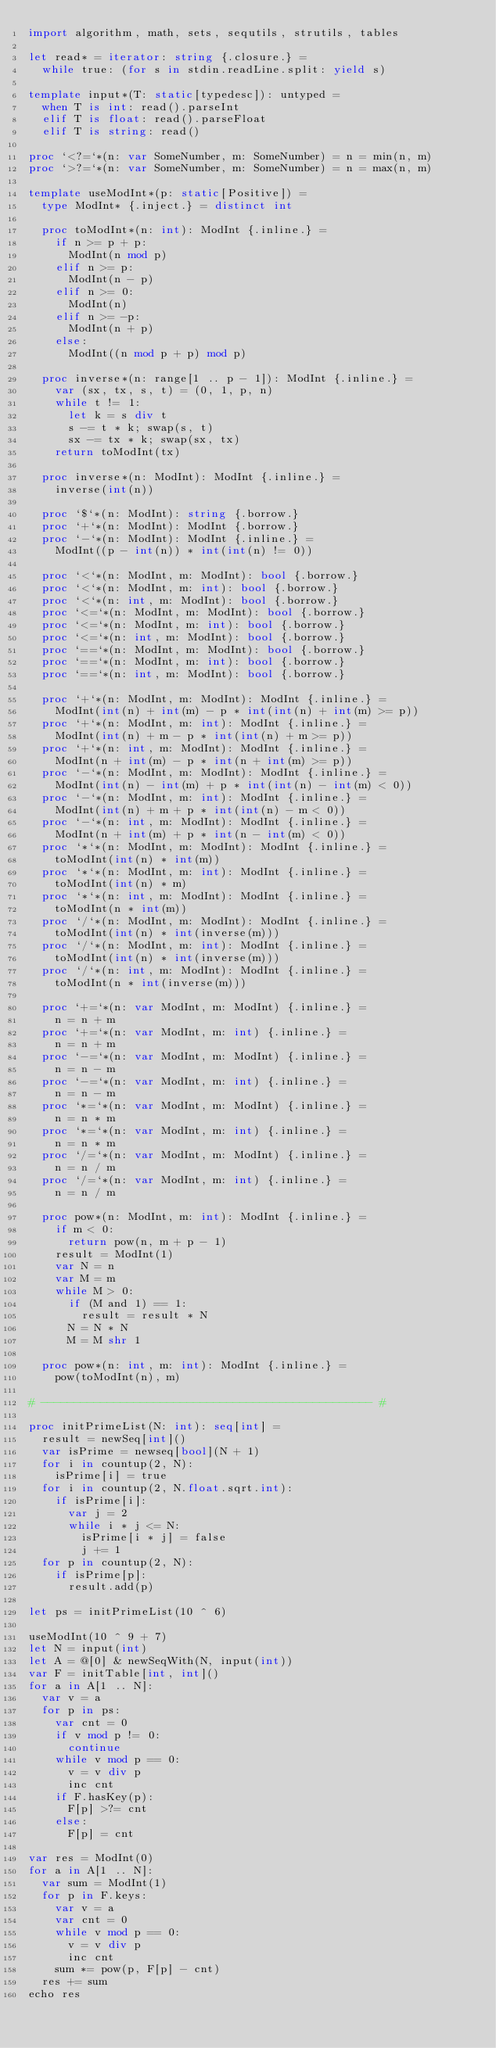Convert code to text. <code><loc_0><loc_0><loc_500><loc_500><_Nim_>import algorithm, math, sets, sequtils, strutils, tables

let read* = iterator: string {.closure.} =
  while true: (for s in stdin.readLine.split: yield s)

template input*(T: static[typedesc]): untyped = 
  when T is int: read().parseInt
  elif T is float: read().parseFloat
  elif T is string: read()

proc `<?=`*(n: var SomeNumber, m: SomeNumber) = n = min(n, m)
proc `>?=`*(n: var SomeNumber, m: SomeNumber) = n = max(n, m)

template useModInt*(p: static[Positive]) =
  type ModInt* {.inject.} = distinct int

  proc toModInt*(n: int): ModInt {.inline.} =
    if n >= p + p:
      ModInt(n mod p)
    elif n >= p:
      ModInt(n - p)
    elif n >= 0:
      ModInt(n)
    elif n >= -p:
      ModInt(n + p)
    else:
      ModInt((n mod p + p) mod p)

  proc inverse*(n: range[1 .. p - 1]): ModInt {.inline.} =
    var (sx, tx, s, t) = (0, 1, p, n)
    while t != 1:
      let k = s div t
      s -= t * k; swap(s, t)
      sx -= tx * k; swap(sx, tx)
    return toModInt(tx)

  proc inverse*(n: ModInt): ModInt {.inline.} =
    inverse(int(n))
    
  proc `$`*(n: ModInt): string {.borrow.}
  proc `+`*(n: ModInt): ModInt {.borrow.}
  proc `-`*(n: ModInt): ModInt {.inline.} =
    ModInt((p - int(n)) * int(int(n) != 0))

  proc `<`*(n: ModInt, m: ModInt): bool {.borrow.}
  proc `<`*(n: ModInt, m: int): bool {.borrow.}
  proc `<`*(n: int, m: ModInt): bool {.borrow.}
  proc `<=`*(n: ModInt, m: ModInt): bool {.borrow.}
  proc `<=`*(n: ModInt, m: int): bool {.borrow.}
  proc `<=`*(n: int, m: ModInt): bool {.borrow.}
  proc `==`*(n: ModInt, m: ModInt): bool {.borrow.}
  proc `==`*(n: ModInt, m: int): bool {.borrow.}
  proc `==`*(n: int, m: ModInt): bool {.borrow.}
 
  proc `+`*(n: ModInt, m: ModInt): ModInt {.inline.} =
    ModInt(int(n) + int(m) - p * int(int(n) + int(m) >= p))
  proc `+`*(n: ModInt, m: int): ModInt {.inline.} =
    ModInt(int(n) + m - p * int(int(n) + m >= p))
  proc `+`*(n: int, m: ModInt): ModInt {.inline.} =
    ModInt(n + int(m) - p * int(n + int(m) >= p))
  proc `-`*(n: ModInt, m: ModInt): ModInt {.inline.} =
    ModInt(int(n) - int(m) + p * int(int(n) - int(m) < 0))
  proc `-`*(n: ModInt, m: int): ModInt {.inline.} =
    ModInt(int(n) + m + p * int(int(n) - m < 0))
  proc `-`*(n: int, m: ModInt): ModInt {.inline.} =
    ModInt(n + int(m) + p * int(n - int(m) < 0))
  proc `*`*(n: ModInt, m: ModInt): ModInt {.inline.} =
    toModInt(int(n) * int(m))
  proc `*`*(n: ModInt, m: int): ModInt {.inline.} =
    toModInt(int(n) * m)
  proc `*`*(n: int, m: ModInt): ModInt {.inline.} =
    toModInt(n * int(m))
  proc `/`*(n: ModInt, m: ModInt): ModInt {.inline.} =
    toModInt(int(n) * int(inverse(m)))
  proc `/`*(n: ModInt, m: int): ModInt {.inline.} =
    toModInt(int(n) * int(inverse(m)))
  proc `/`*(n: int, m: ModInt): ModInt {.inline.} =
    toModInt(n * int(inverse(m)))

  proc `+=`*(n: var ModInt, m: ModInt) {.inline.} =
    n = n + m
  proc `+=`*(n: var ModInt, m: int) {.inline.} =
    n = n + m
  proc `-=`*(n: var ModInt, m: ModInt) {.inline.} =
    n = n - m
  proc `-=`*(n: var ModInt, m: int) {.inline.} =
    n = n - m
  proc `*=`*(n: var ModInt, m: ModInt) {.inline.} =
    n = n * m
  proc `*=`*(n: var ModInt, m: int) {.inline.} =
    n = n * m
  proc `/=`*(n: var ModInt, m: ModInt) {.inline.} =
    n = n / m
  proc `/=`*(n: var ModInt, m: int) {.inline.} =
    n = n / m

  proc pow*(n: ModInt, m: int): ModInt {.inline.} =
    if m < 0:
      return pow(n, m + p - 1)
    result = ModInt(1)
    var N = n
    var M = m
    while M > 0:
      if (M and 1) == 1:
        result = result * N
      N = N * N
      M = M shr 1

  proc pow*(n: int, m: int): ModInt {.inline.} =
    pow(toModInt(n), m)

# -------------------------------------------------- #

proc initPrimeList(N: int): seq[int] =
  result = newSeq[int]()
  var isPrime = newseq[bool](N + 1)
  for i in countup(2, N):
    isPrime[i] = true
  for i in countup(2, N.float.sqrt.int):
    if isPrime[i]:
      var j = 2
      while i * j <= N:
        isPrime[i * j] = false
        j += 1
  for p in countup(2, N):
    if isPrime[p]:
      result.add(p)

let ps = initPrimeList(10 ^ 6)

useModInt(10 ^ 9 + 7)
let N = input(int)
let A = @[0] & newSeqWith(N, input(int))
var F = initTable[int, int]()
for a in A[1 .. N]:
  var v = a
  for p in ps:
    var cnt = 0
    if v mod p != 0:
      continue
    while v mod p == 0:
      v = v div p
      inc cnt
    if F.hasKey(p):
      F[p] >?= cnt
    else:
      F[p] = cnt

var res = ModInt(0)
for a in A[1 .. N]:
  var sum = ModInt(1)
  for p in F.keys:
    var v = a
    var cnt = 0
    while v mod p == 0:
      v = v div p
      inc cnt
    sum *= pow(p, F[p] - cnt)
  res += sum
echo res</code> 